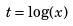<formula> <loc_0><loc_0><loc_500><loc_500>t = \log ( x )</formula> 